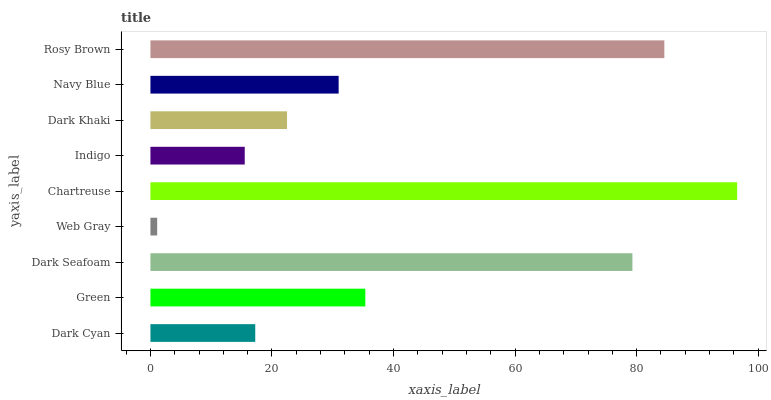Is Web Gray the minimum?
Answer yes or no. Yes. Is Chartreuse the maximum?
Answer yes or no. Yes. Is Green the minimum?
Answer yes or no. No. Is Green the maximum?
Answer yes or no. No. Is Green greater than Dark Cyan?
Answer yes or no. Yes. Is Dark Cyan less than Green?
Answer yes or no. Yes. Is Dark Cyan greater than Green?
Answer yes or no. No. Is Green less than Dark Cyan?
Answer yes or no. No. Is Navy Blue the high median?
Answer yes or no. Yes. Is Navy Blue the low median?
Answer yes or no. Yes. Is Dark Cyan the high median?
Answer yes or no. No. Is Green the low median?
Answer yes or no. No. 